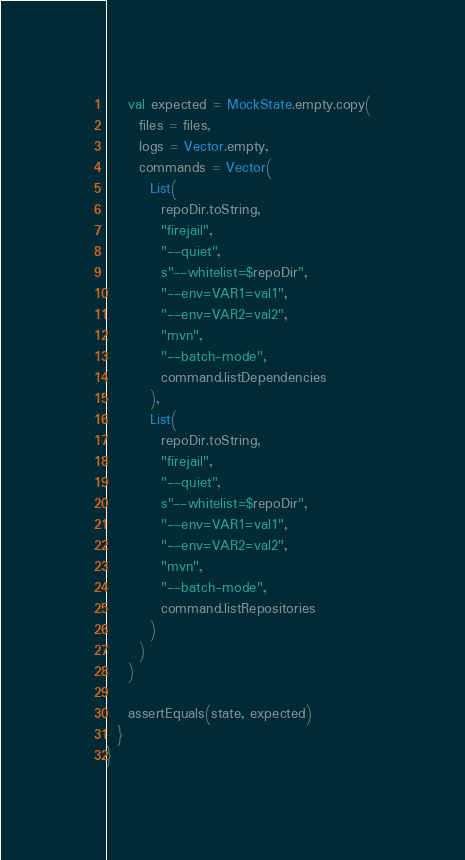Convert code to text. <code><loc_0><loc_0><loc_500><loc_500><_Scala_>
    val expected = MockState.empty.copy(
      files = files,
      logs = Vector.empty,
      commands = Vector(
        List(
          repoDir.toString,
          "firejail",
          "--quiet",
          s"--whitelist=$repoDir",
          "--env=VAR1=val1",
          "--env=VAR2=val2",
          "mvn",
          "--batch-mode",
          command.listDependencies
        ),
        List(
          repoDir.toString,
          "firejail",
          "--quiet",
          s"--whitelist=$repoDir",
          "--env=VAR1=val1",
          "--env=VAR2=val2",
          "mvn",
          "--batch-mode",
          command.listRepositories
        )
      )
    )

    assertEquals(state, expected)
  }
}
</code> 